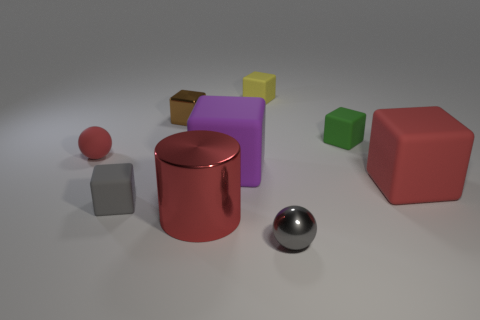Subtract all purple rubber blocks. How many blocks are left? 5 Subtract all yellow cubes. How many cubes are left? 5 Subtract all purple cubes. Subtract all red balls. How many cubes are left? 5 Add 1 large blocks. How many objects exist? 10 Subtract all spheres. How many objects are left? 7 Add 4 green things. How many green things exist? 5 Subtract 0 cyan spheres. How many objects are left? 9 Subtract all large red objects. Subtract all small objects. How many objects are left? 1 Add 2 large metal cylinders. How many large metal cylinders are left? 3 